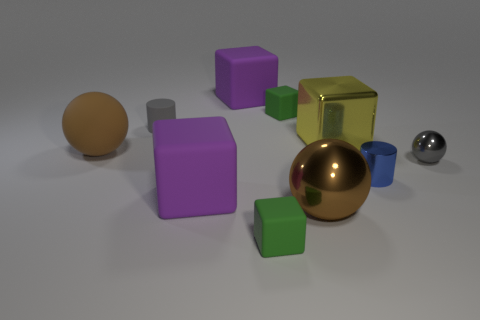Subtract all green cubes. How many were subtracted if there are1green cubes left? 1 Subtract all yellow cubes. How many cubes are left? 4 Subtract all yellow cubes. How many cubes are left? 4 Subtract all blue blocks. Subtract all cyan spheres. How many blocks are left? 5 Subtract all balls. How many objects are left? 7 Subtract 0 yellow cylinders. How many objects are left? 10 Subtract all gray rubber objects. Subtract all brown things. How many objects are left? 7 Add 7 shiny spheres. How many shiny spheres are left? 9 Add 7 small cyan metal blocks. How many small cyan metal blocks exist? 7 